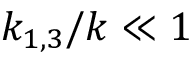Convert formula to latex. <formula><loc_0><loc_0><loc_500><loc_500>k _ { 1 , 3 } / k \ll 1</formula> 